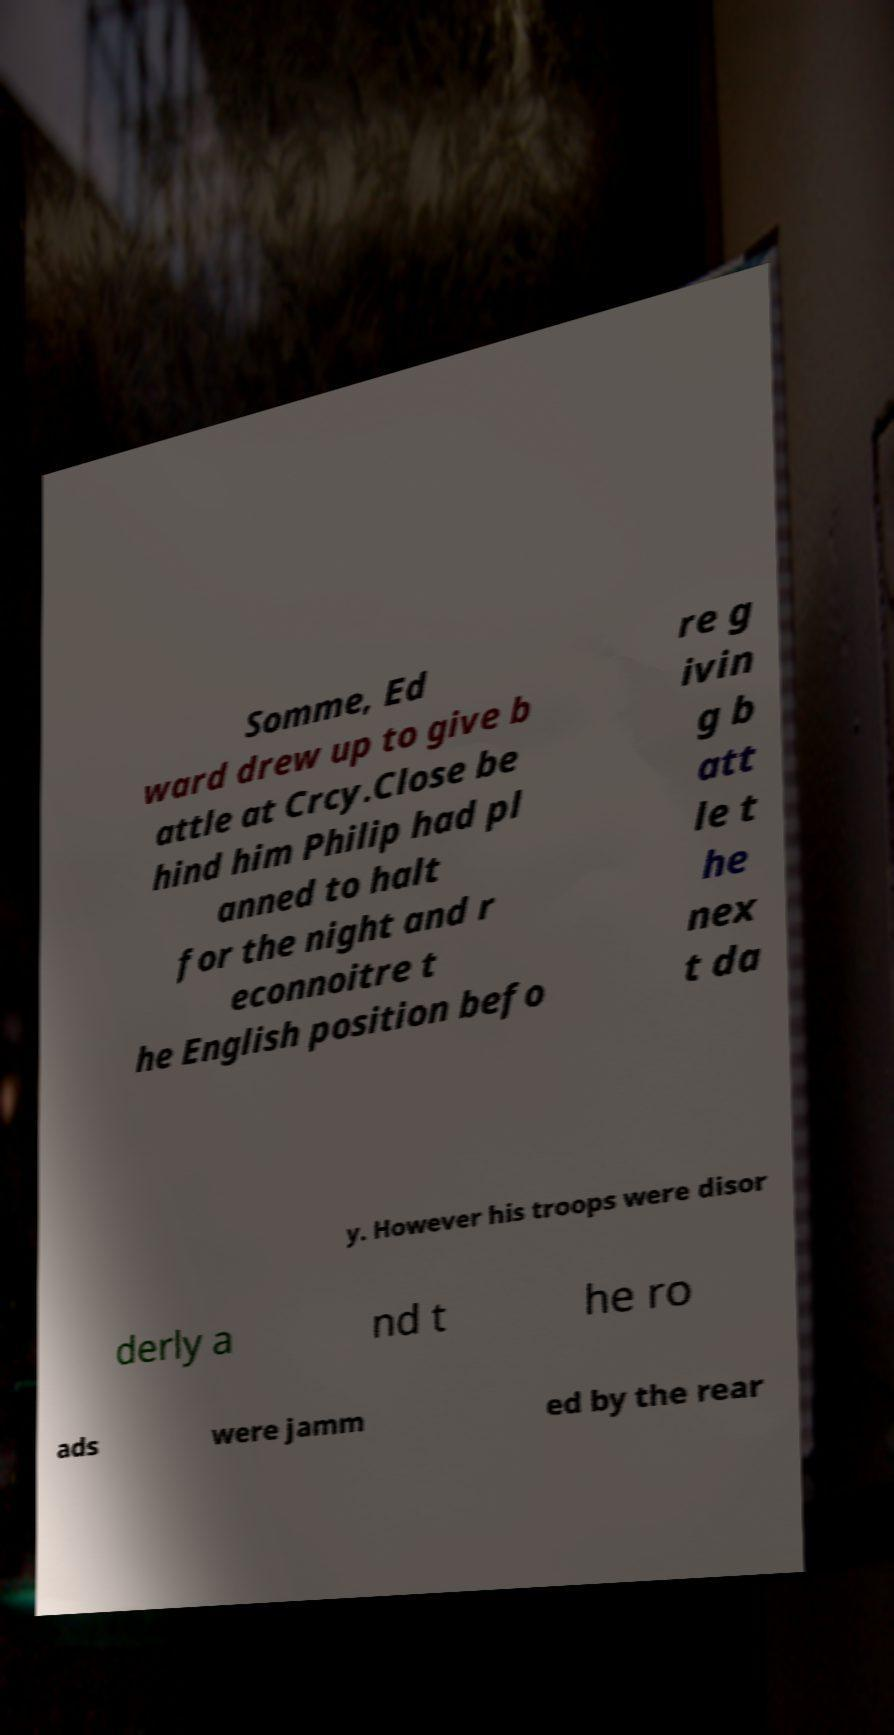Could you assist in decoding the text presented in this image and type it out clearly? Somme, Ed ward drew up to give b attle at Crcy.Close be hind him Philip had pl anned to halt for the night and r econnoitre t he English position befo re g ivin g b att le t he nex t da y. However his troops were disor derly a nd t he ro ads were jamm ed by the rear 